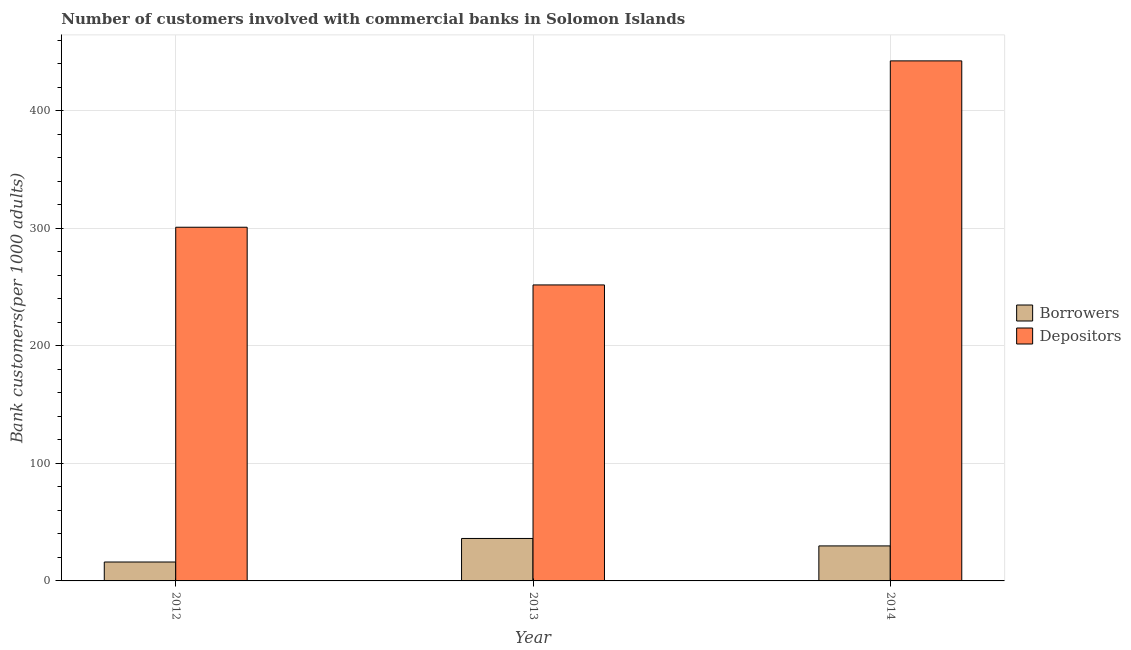How many different coloured bars are there?
Keep it short and to the point. 2. Are the number of bars on each tick of the X-axis equal?
Ensure brevity in your answer.  Yes. How many bars are there on the 2nd tick from the left?
Your answer should be very brief. 2. How many bars are there on the 1st tick from the right?
Your response must be concise. 2. What is the label of the 1st group of bars from the left?
Ensure brevity in your answer.  2012. In how many cases, is the number of bars for a given year not equal to the number of legend labels?
Your answer should be very brief. 0. What is the number of borrowers in 2014?
Your answer should be very brief. 29.78. Across all years, what is the maximum number of depositors?
Offer a very short reply. 442.39. Across all years, what is the minimum number of borrowers?
Provide a short and direct response. 16.09. What is the total number of depositors in the graph?
Your answer should be compact. 995.05. What is the difference between the number of depositors in 2012 and that in 2013?
Offer a terse response. 49.08. What is the difference between the number of borrowers in 2012 and the number of depositors in 2013?
Your answer should be compact. -20.03. What is the average number of depositors per year?
Provide a succinct answer. 331.68. In the year 2014, what is the difference between the number of depositors and number of borrowers?
Provide a short and direct response. 0. In how many years, is the number of depositors greater than 300?
Make the answer very short. 2. What is the ratio of the number of borrowers in 2012 to that in 2013?
Give a very brief answer. 0.45. Is the number of borrowers in 2012 less than that in 2013?
Offer a terse response. Yes. Is the difference between the number of depositors in 2012 and 2013 greater than the difference between the number of borrowers in 2012 and 2013?
Offer a terse response. No. What is the difference between the highest and the second highest number of depositors?
Your answer should be very brief. 141.52. What is the difference between the highest and the lowest number of borrowers?
Give a very brief answer. 20.03. In how many years, is the number of borrowers greater than the average number of borrowers taken over all years?
Provide a short and direct response. 2. Is the sum of the number of borrowers in 2012 and 2013 greater than the maximum number of depositors across all years?
Your response must be concise. Yes. What does the 1st bar from the left in 2014 represents?
Your answer should be very brief. Borrowers. What does the 1st bar from the right in 2014 represents?
Offer a very short reply. Depositors. Are all the bars in the graph horizontal?
Your response must be concise. No. How many years are there in the graph?
Keep it short and to the point. 3. What is the difference between two consecutive major ticks on the Y-axis?
Give a very brief answer. 100. Are the values on the major ticks of Y-axis written in scientific E-notation?
Offer a terse response. No. Does the graph contain grids?
Offer a very short reply. Yes. How many legend labels are there?
Keep it short and to the point. 2. How are the legend labels stacked?
Keep it short and to the point. Vertical. What is the title of the graph?
Provide a succinct answer. Number of customers involved with commercial banks in Solomon Islands. Does "Technicians" appear as one of the legend labels in the graph?
Give a very brief answer. No. What is the label or title of the X-axis?
Your answer should be very brief. Year. What is the label or title of the Y-axis?
Your answer should be compact. Bank customers(per 1000 adults). What is the Bank customers(per 1000 adults) of Borrowers in 2012?
Your response must be concise. 16.09. What is the Bank customers(per 1000 adults) of Depositors in 2012?
Ensure brevity in your answer.  300.87. What is the Bank customers(per 1000 adults) of Borrowers in 2013?
Your answer should be compact. 36.11. What is the Bank customers(per 1000 adults) of Depositors in 2013?
Your answer should be compact. 251.79. What is the Bank customers(per 1000 adults) of Borrowers in 2014?
Make the answer very short. 29.78. What is the Bank customers(per 1000 adults) in Depositors in 2014?
Give a very brief answer. 442.39. Across all years, what is the maximum Bank customers(per 1000 adults) of Borrowers?
Your answer should be very brief. 36.11. Across all years, what is the maximum Bank customers(per 1000 adults) of Depositors?
Your answer should be compact. 442.39. Across all years, what is the minimum Bank customers(per 1000 adults) in Borrowers?
Your response must be concise. 16.09. Across all years, what is the minimum Bank customers(per 1000 adults) of Depositors?
Ensure brevity in your answer.  251.79. What is the total Bank customers(per 1000 adults) in Borrowers in the graph?
Keep it short and to the point. 81.98. What is the total Bank customers(per 1000 adults) of Depositors in the graph?
Offer a very short reply. 995.05. What is the difference between the Bank customers(per 1000 adults) of Borrowers in 2012 and that in 2013?
Ensure brevity in your answer.  -20.03. What is the difference between the Bank customers(per 1000 adults) in Depositors in 2012 and that in 2013?
Offer a terse response. 49.08. What is the difference between the Bank customers(per 1000 adults) in Borrowers in 2012 and that in 2014?
Make the answer very short. -13.69. What is the difference between the Bank customers(per 1000 adults) in Depositors in 2012 and that in 2014?
Make the answer very short. -141.52. What is the difference between the Bank customers(per 1000 adults) in Borrowers in 2013 and that in 2014?
Your response must be concise. 6.33. What is the difference between the Bank customers(per 1000 adults) of Depositors in 2013 and that in 2014?
Ensure brevity in your answer.  -190.6. What is the difference between the Bank customers(per 1000 adults) of Borrowers in 2012 and the Bank customers(per 1000 adults) of Depositors in 2013?
Give a very brief answer. -235.7. What is the difference between the Bank customers(per 1000 adults) of Borrowers in 2012 and the Bank customers(per 1000 adults) of Depositors in 2014?
Your answer should be very brief. -426.3. What is the difference between the Bank customers(per 1000 adults) of Borrowers in 2013 and the Bank customers(per 1000 adults) of Depositors in 2014?
Your answer should be very brief. -406.28. What is the average Bank customers(per 1000 adults) of Borrowers per year?
Keep it short and to the point. 27.33. What is the average Bank customers(per 1000 adults) of Depositors per year?
Ensure brevity in your answer.  331.68. In the year 2012, what is the difference between the Bank customers(per 1000 adults) in Borrowers and Bank customers(per 1000 adults) in Depositors?
Provide a short and direct response. -284.79. In the year 2013, what is the difference between the Bank customers(per 1000 adults) in Borrowers and Bank customers(per 1000 adults) in Depositors?
Provide a succinct answer. -215.68. In the year 2014, what is the difference between the Bank customers(per 1000 adults) in Borrowers and Bank customers(per 1000 adults) in Depositors?
Your answer should be compact. -412.61. What is the ratio of the Bank customers(per 1000 adults) of Borrowers in 2012 to that in 2013?
Provide a succinct answer. 0.45. What is the ratio of the Bank customers(per 1000 adults) in Depositors in 2012 to that in 2013?
Make the answer very short. 1.19. What is the ratio of the Bank customers(per 1000 adults) of Borrowers in 2012 to that in 2014?
Offer a terse response. 0.54. What is the ratio of the Bank customers(per 1000 adults) in Depositors in 2012 to that in 2014?
Provide a succinct answer. 0.68. What is the ratio of the Bank customers(per 1000 adults) in Borrowers in 2013 to that in 2014?
Your response must be concise. 1.21. What is the ratio of the Bank customers(per 1000 adults) of Depositors in 2013 to that in 2014?
Provide a succinct answer. 0.57. What is the difference between the highest and the second highest Bank customers(per 1000 adults) of Borrowers?
Your answer should be very brief. 6.33. What is the difference between the highest and the second highest Bank customers(per 1000 adults) of Depositors?
Keep it short and to the point. 141.52. What is the difference between the highest and the lowest Bank customers(per 1000 adults) of Borrowers?
Your answer should be very brief. 20.03. What is the difference between the highest and the lowest Bank customers(per 1000 adults) in Depositors?
Offer a terse response. 190.6. 